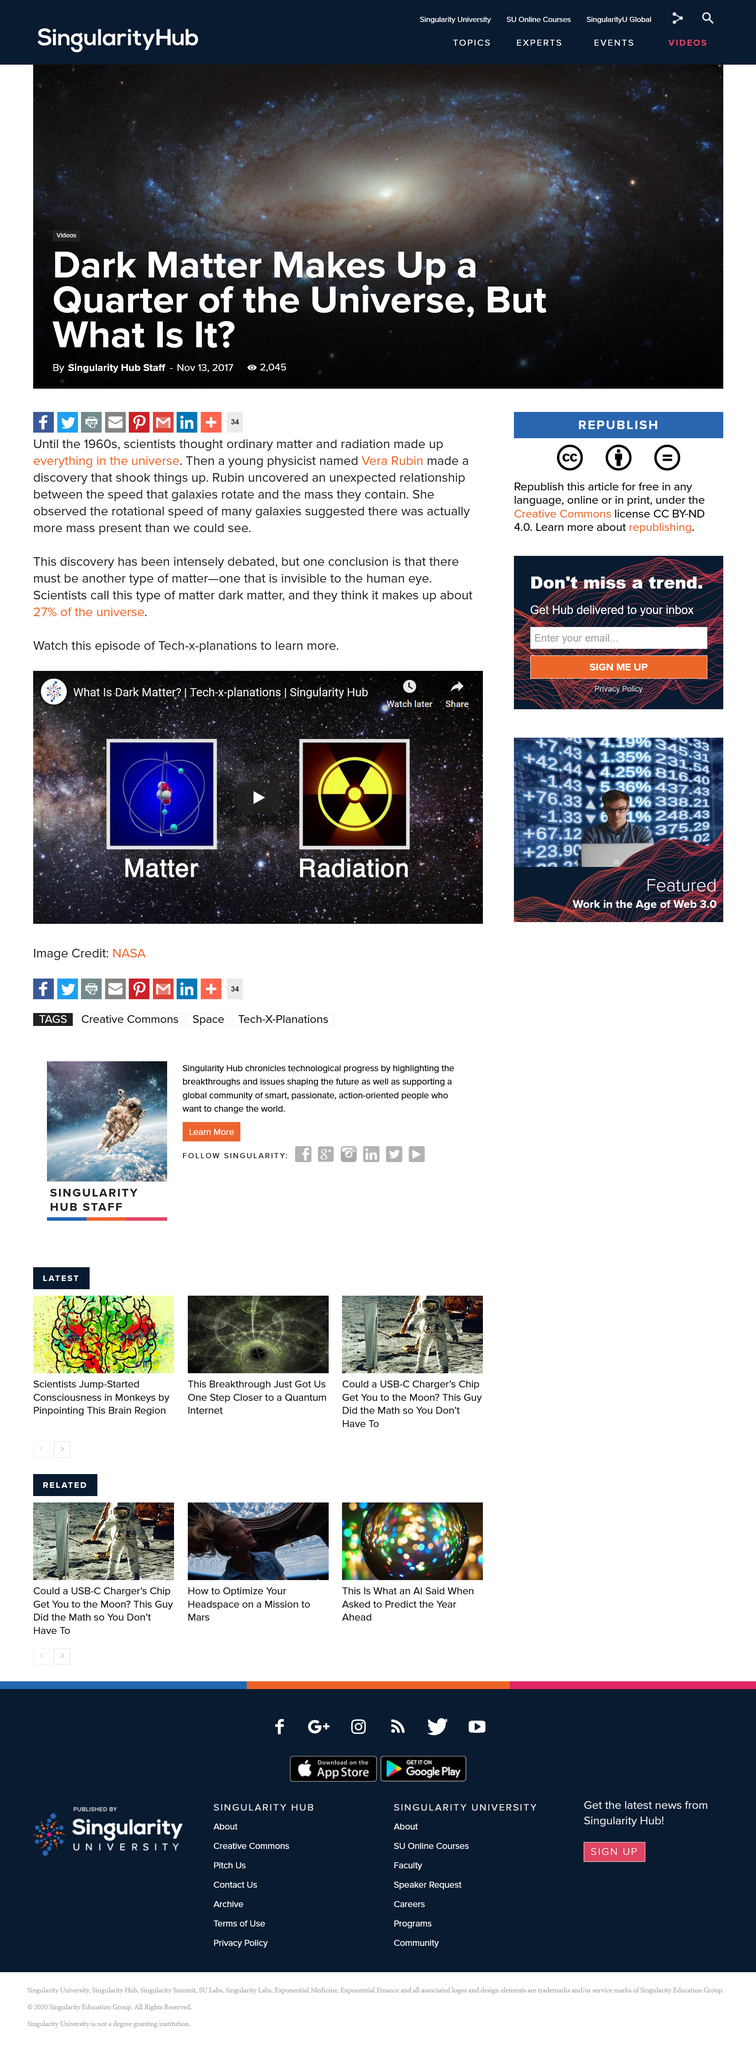Mention a couple of crucial points in this snapshot. The discovery made by Vera Rubin has been intensely debated. Vera Rubin discovered an unexpected relationship between the speed that galaxies rotate and the mass they contain, which challenged the previously held belief that the mass of a galaxy determines its speed of rotation. Dark matter is estimated to account for approximately 27% of the universe. 